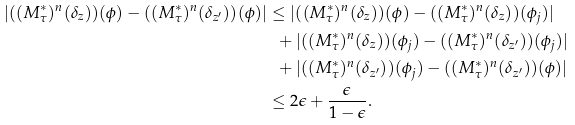<formula> <loc_0><loc_0><loc_500><loc_500>| ( ( M _ { \tau } ^ { \ast } ) ^ { n } ( \delta _ { z } ) ) ( \phi ) - ( ( M _ { \tau } ^ { \ast } ) ^ { n } ( \delta _ { z ^ { \prime } } ) ) ( \phi ) | & \leq | ( ( M _ { \tau } ^ { \ast } ) ^ { n } ( \delta _ { z } ) ) ( \phi ) - ( ( M _ { \tau } ^ { \ast } ) ^ { n } ( \delta _ { z } ) ) ( \phi _ { j } ) | \\ & \ \ + | ( ( M _ { \tau } ^ { \ast } ) ^ { n } ( \delta _ { z } ) ) ( \phi _ { j } ) - ( ( M _ { \tau } ^ { \ast } ) ^ { n } ( \delta _ { z ^ { \prime } } ) ) ( \phi _ { j } ) | \\ & \ \ + | ( ( M _ { \tau } ^ { \ast } ) ^ { n } ( \delta _ { z ^ { \prime } } ) ) ( \phi _ { j } ) - ( ( M _ { \tau } ^ { \ast } ) ^ { n } ( \delta _ { z ^ { \prime } } ) ) ( \phi ) | \\ & \leq 2 \epsilon + \frac { \epsilon } { 1 - \epsilon } .</formula> 